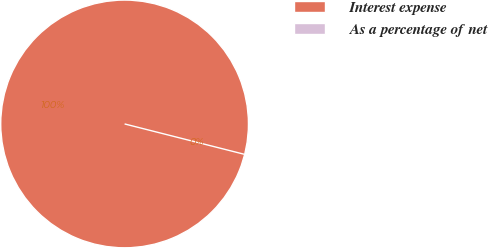Convert chart to OTSL. <chart><loc_0><loc_0><loc_500><loc_500><pie_chart><fcel>Interest expense<fcel>As a percentage of net<nl><fcel>100.0%<fcel>0.0%<nl></chart> 